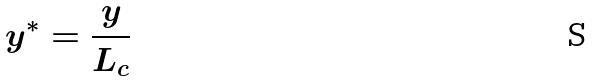Convert formula to latex. <formula><loc_0><loc_0><loc_500><loc_500>y ^ { * } = \frac { y } { L _ { c } }</formula> 